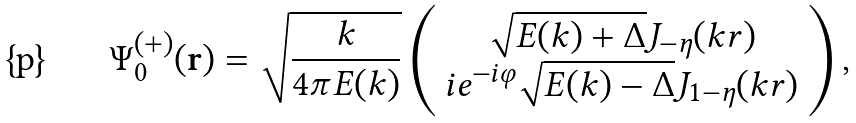<formula> <loc_0><loc_0><loc_500><loc_500>\Psi ^ { ( + ) } _ { 0 } ( { \mathbf r } ) = \sqrt { \frac { k } { 4 \pi E ( k ) } } \left ( \begin{array} { c c } \sqrt { E ( k ) + \Delta } J _ { - \eta } ( k r ) \\ i e ^ { - i \varphi } \sqrt { E ( k ) - \Delta } J _ { 1 - \eta } ( k r ) \end{array} \right ) ,</formula> 